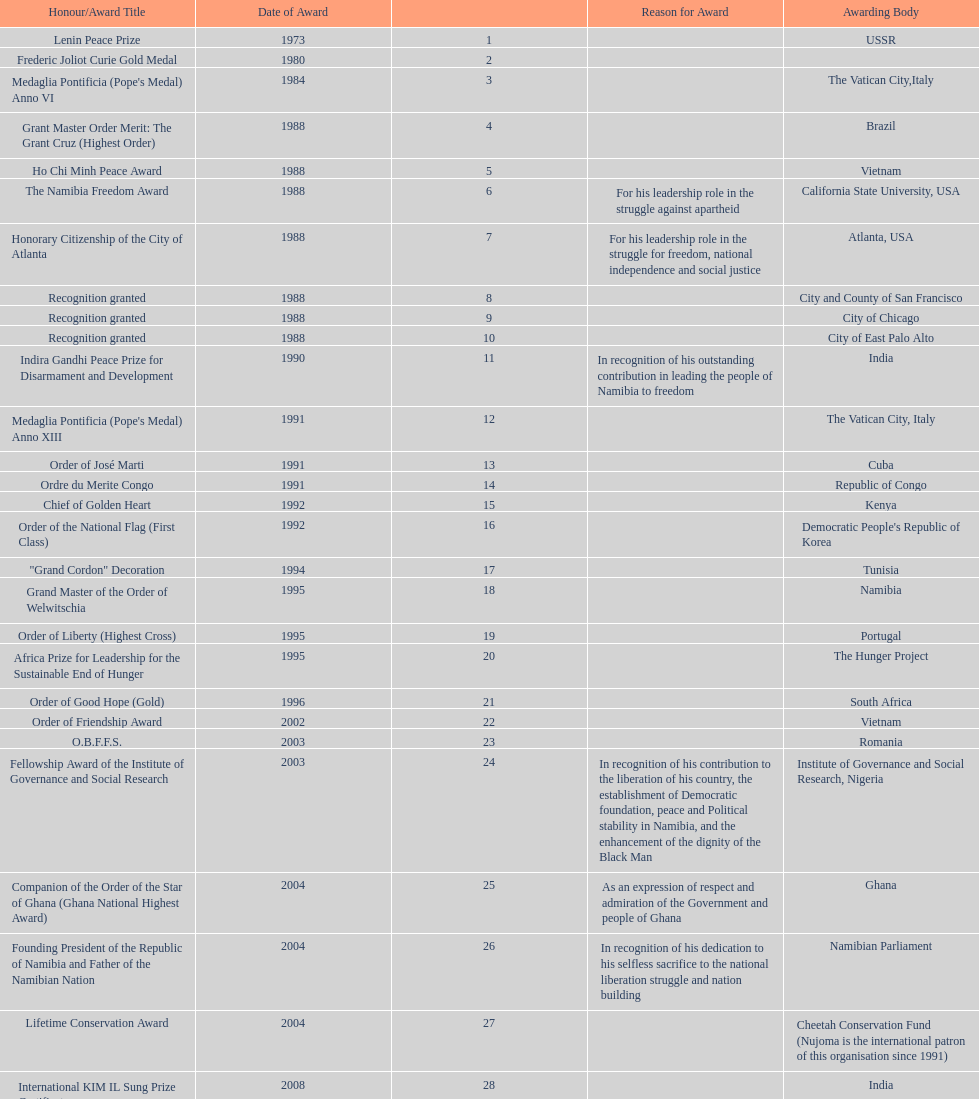What is the most recent award nujoma received? Sir Seretse Khama SADC Meda. 